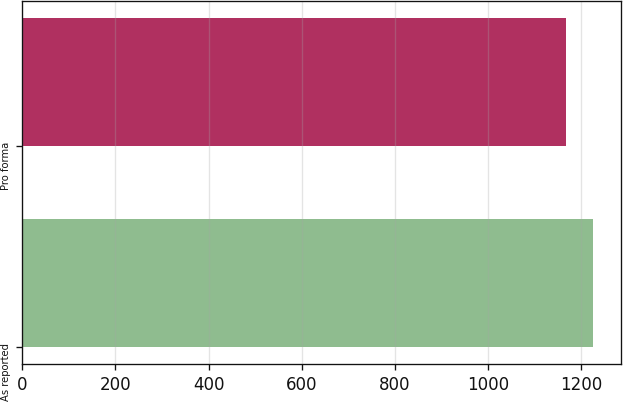<chart> <loc_0><loc_0><loc_500><loc_500><bar_chart><fcel>As reported<fcel>Pro forma<nl><fcel>1224<fcel>1166<nl></chart> 